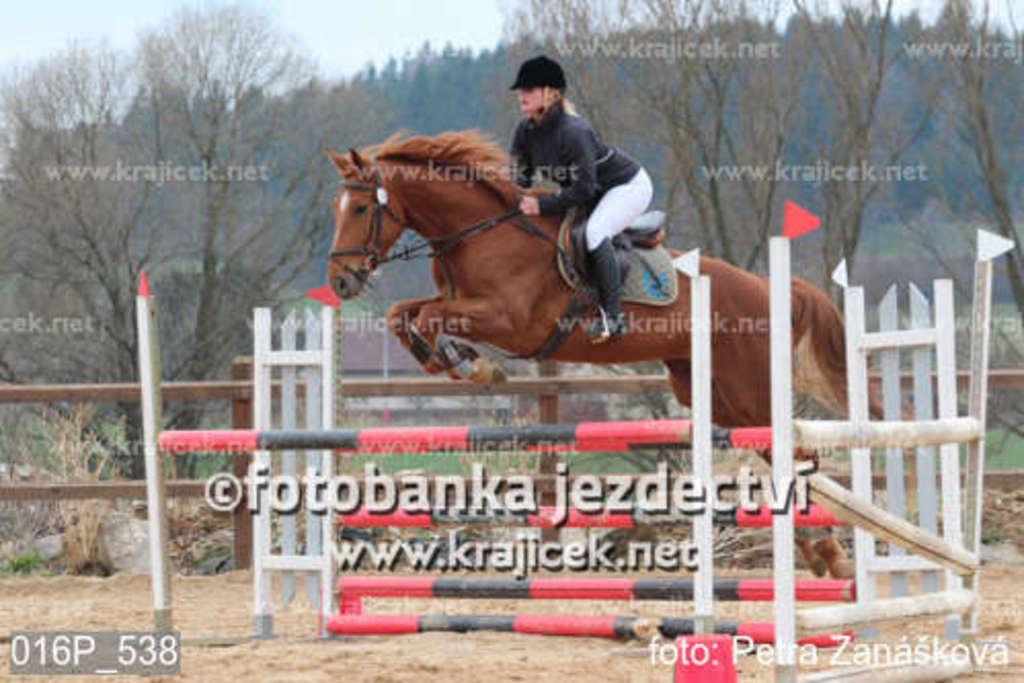Who is the main subject in the image? There is a woman in the image. What is the woman doing in the image? The woman is riding a horse. What can be seen in the background of the image? There are trees visible in the image. What type of scissors can be seen in the woman's hand while riding the horse? There are no scissors present in the image; the woman is riding a horse and there are trees visible in the background. 